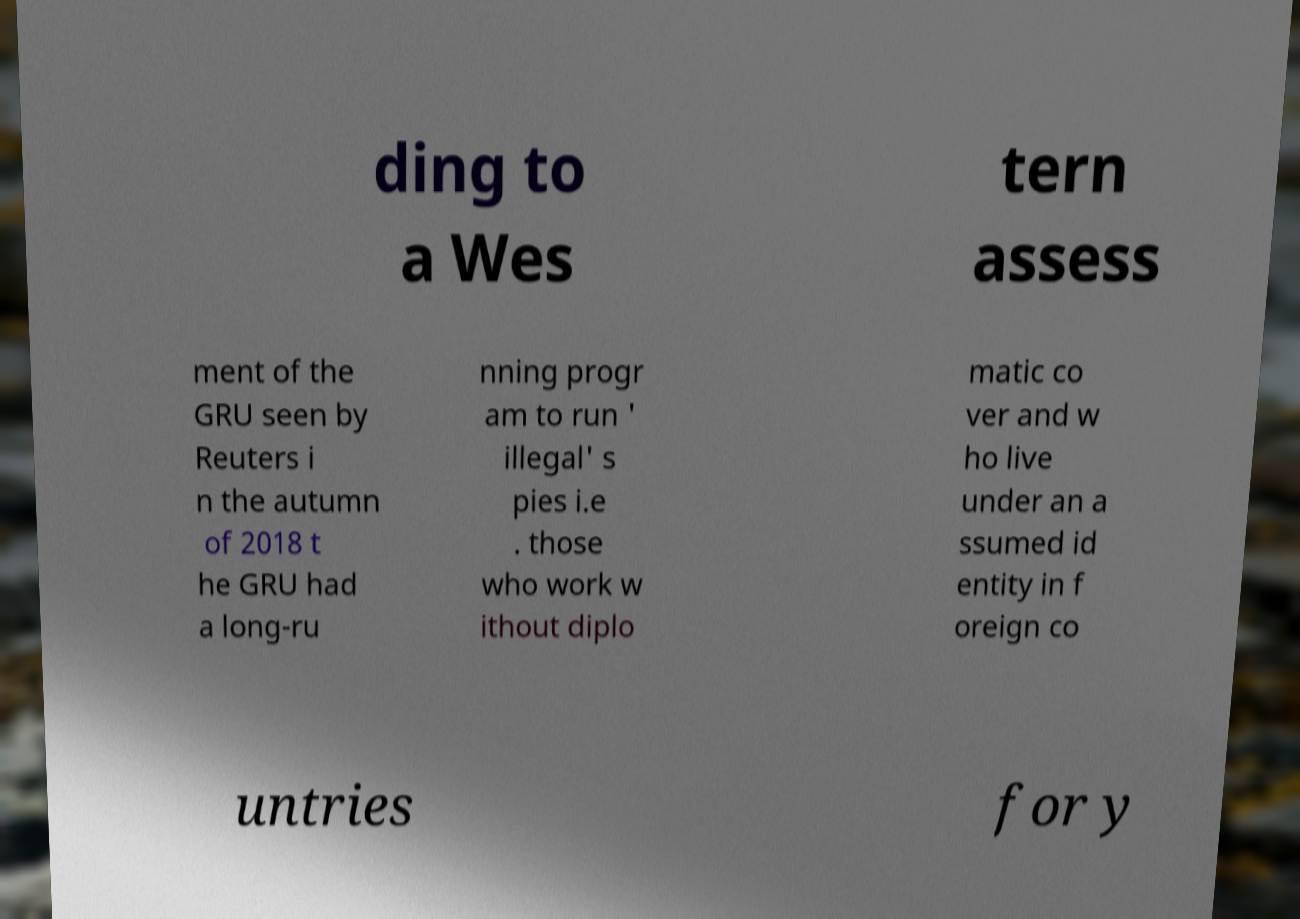Can you accurately transcribe the text from the provided image for me? ding to a Wes tern assess ment of the GRU seen by Reuters i n the autumn of 2018 t he GRU had a long-ru nning progr am to run ' illegal' s pies i.e . those who work w ithout diplo matic co ver and w ho live under an a ssumed id entity in f oreign co untries for y 